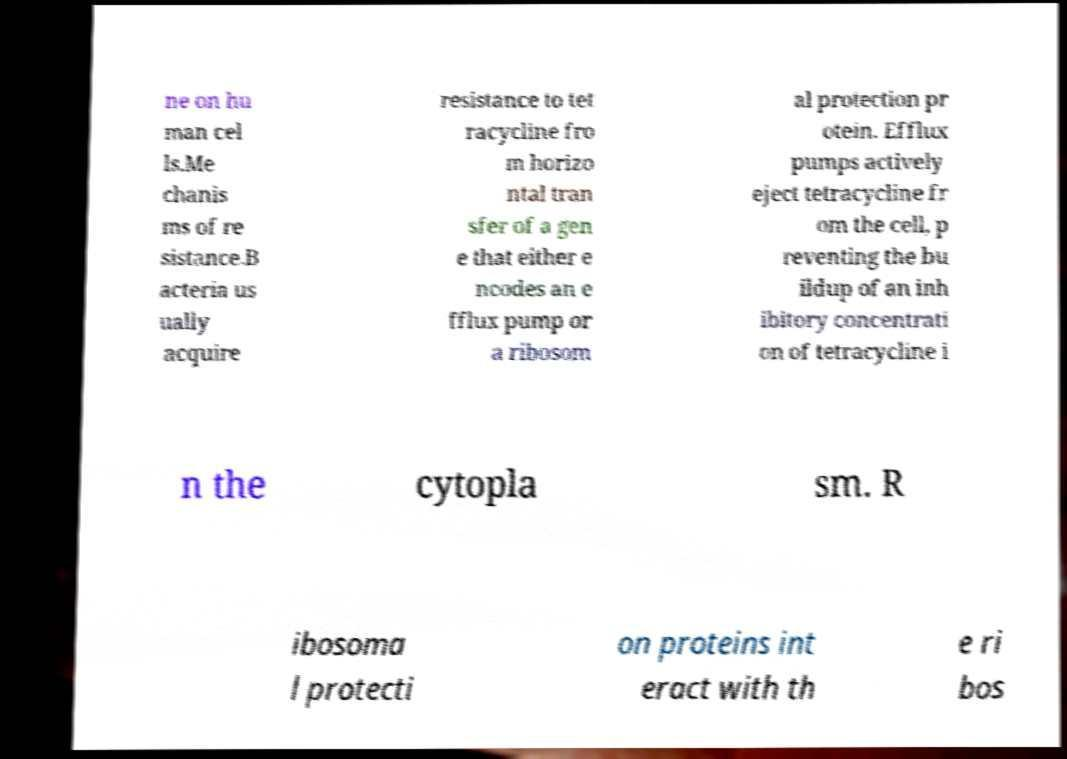Please identify and transcribe the text found in this image. ne on hu man cel ls.Me chanis ms of re sistance.B acteria us ually acquire resistance to tet racycline fro m horizo ntal tran sfer of a gen e that either e ncodes an e fflux pump or a ribosom al protection pr otein. Efflux pumps actively eject tetracycline fr om the cell, p reventing the bu ildup of an inh ibitory concentrati on of tetracycline i n the cytopla sm. R ibosoma l protecti on proteins int eract with th e ri bos 